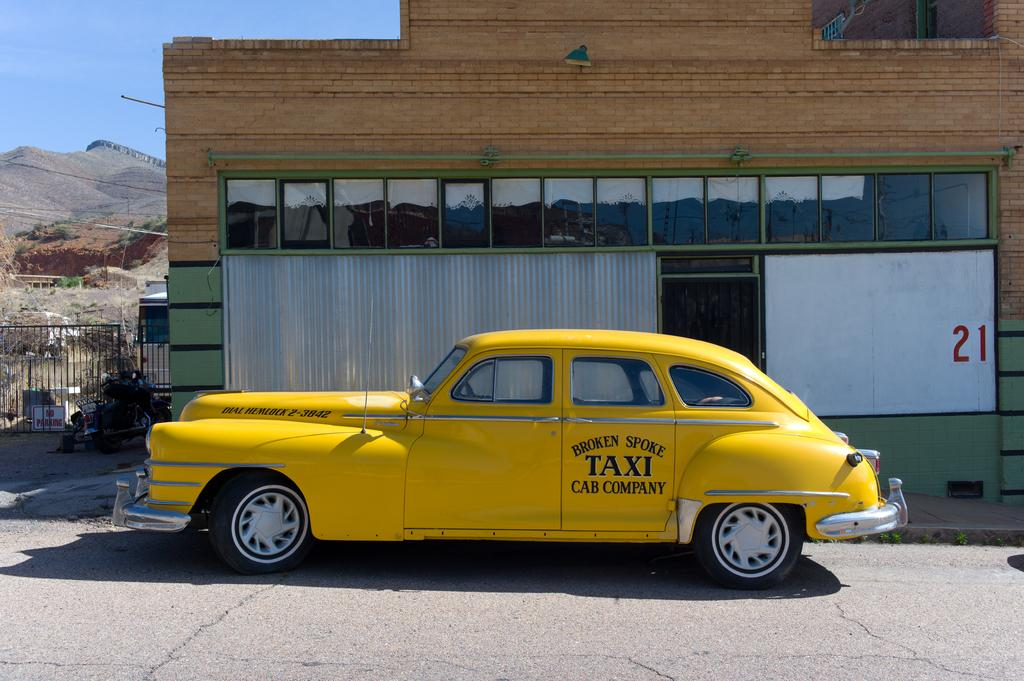<image>
Create a compact narrative representing the image presented. A yellow antique taxi is from the Broken Spike Cab Company. 